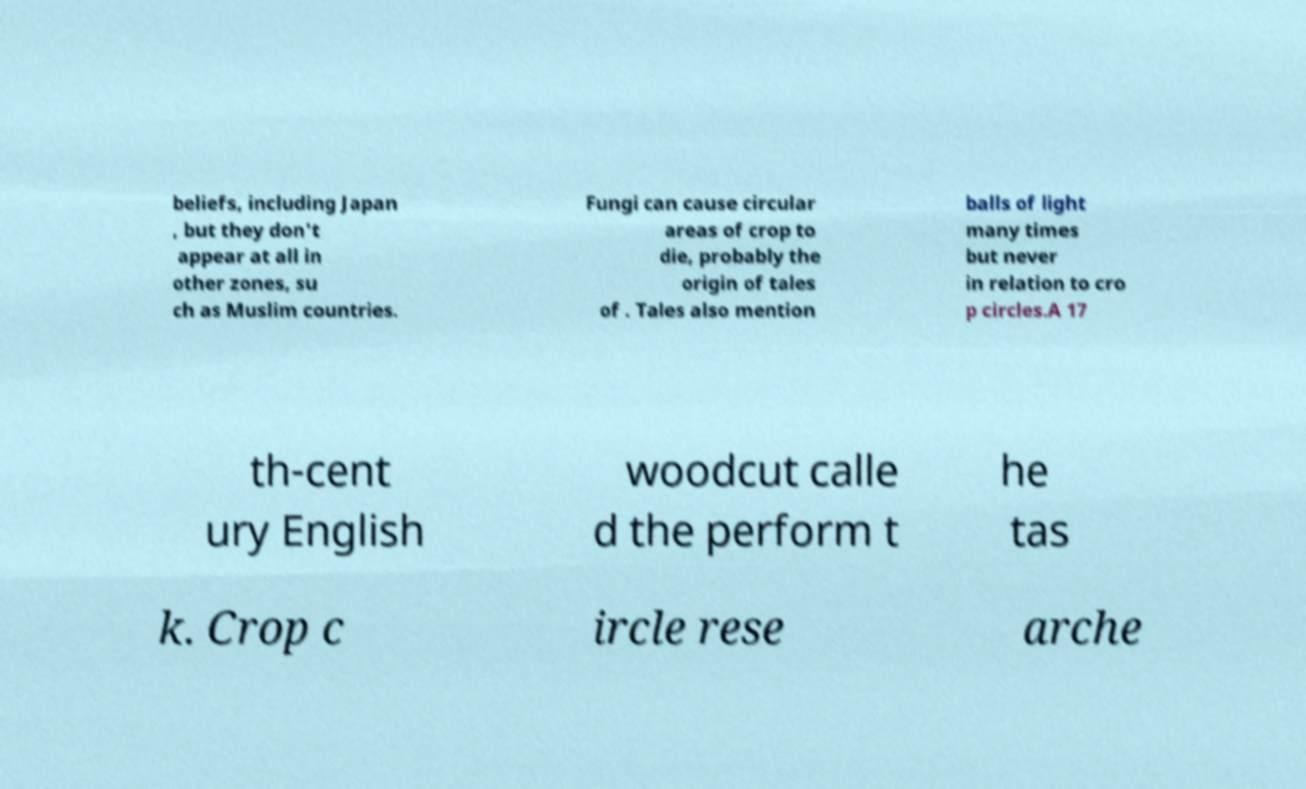What messages or text are displayed in this image? I need them in a readable, typed format. beliefs, including Japan , but they don't appear at all in other zones, su ch as Muslim countries. Fungi can cause circular areas of crop to die, probably the origin of tales of . Tales also mention balls of light many times but never in relation to cro p circles.A 17 th-cent ury English woodcut calle d the perform t he tas k. Crop c ircle rese arche 